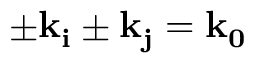<formula> <loc_0><loc_0><loc_500><loc_500>\pm k _ { i } \pm k _ { j } = k _ { 0 }</formula> 